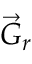<formula> <loc_0><loc_0><loc_500><loc_500>\vec { G } _ { r }</formula> 